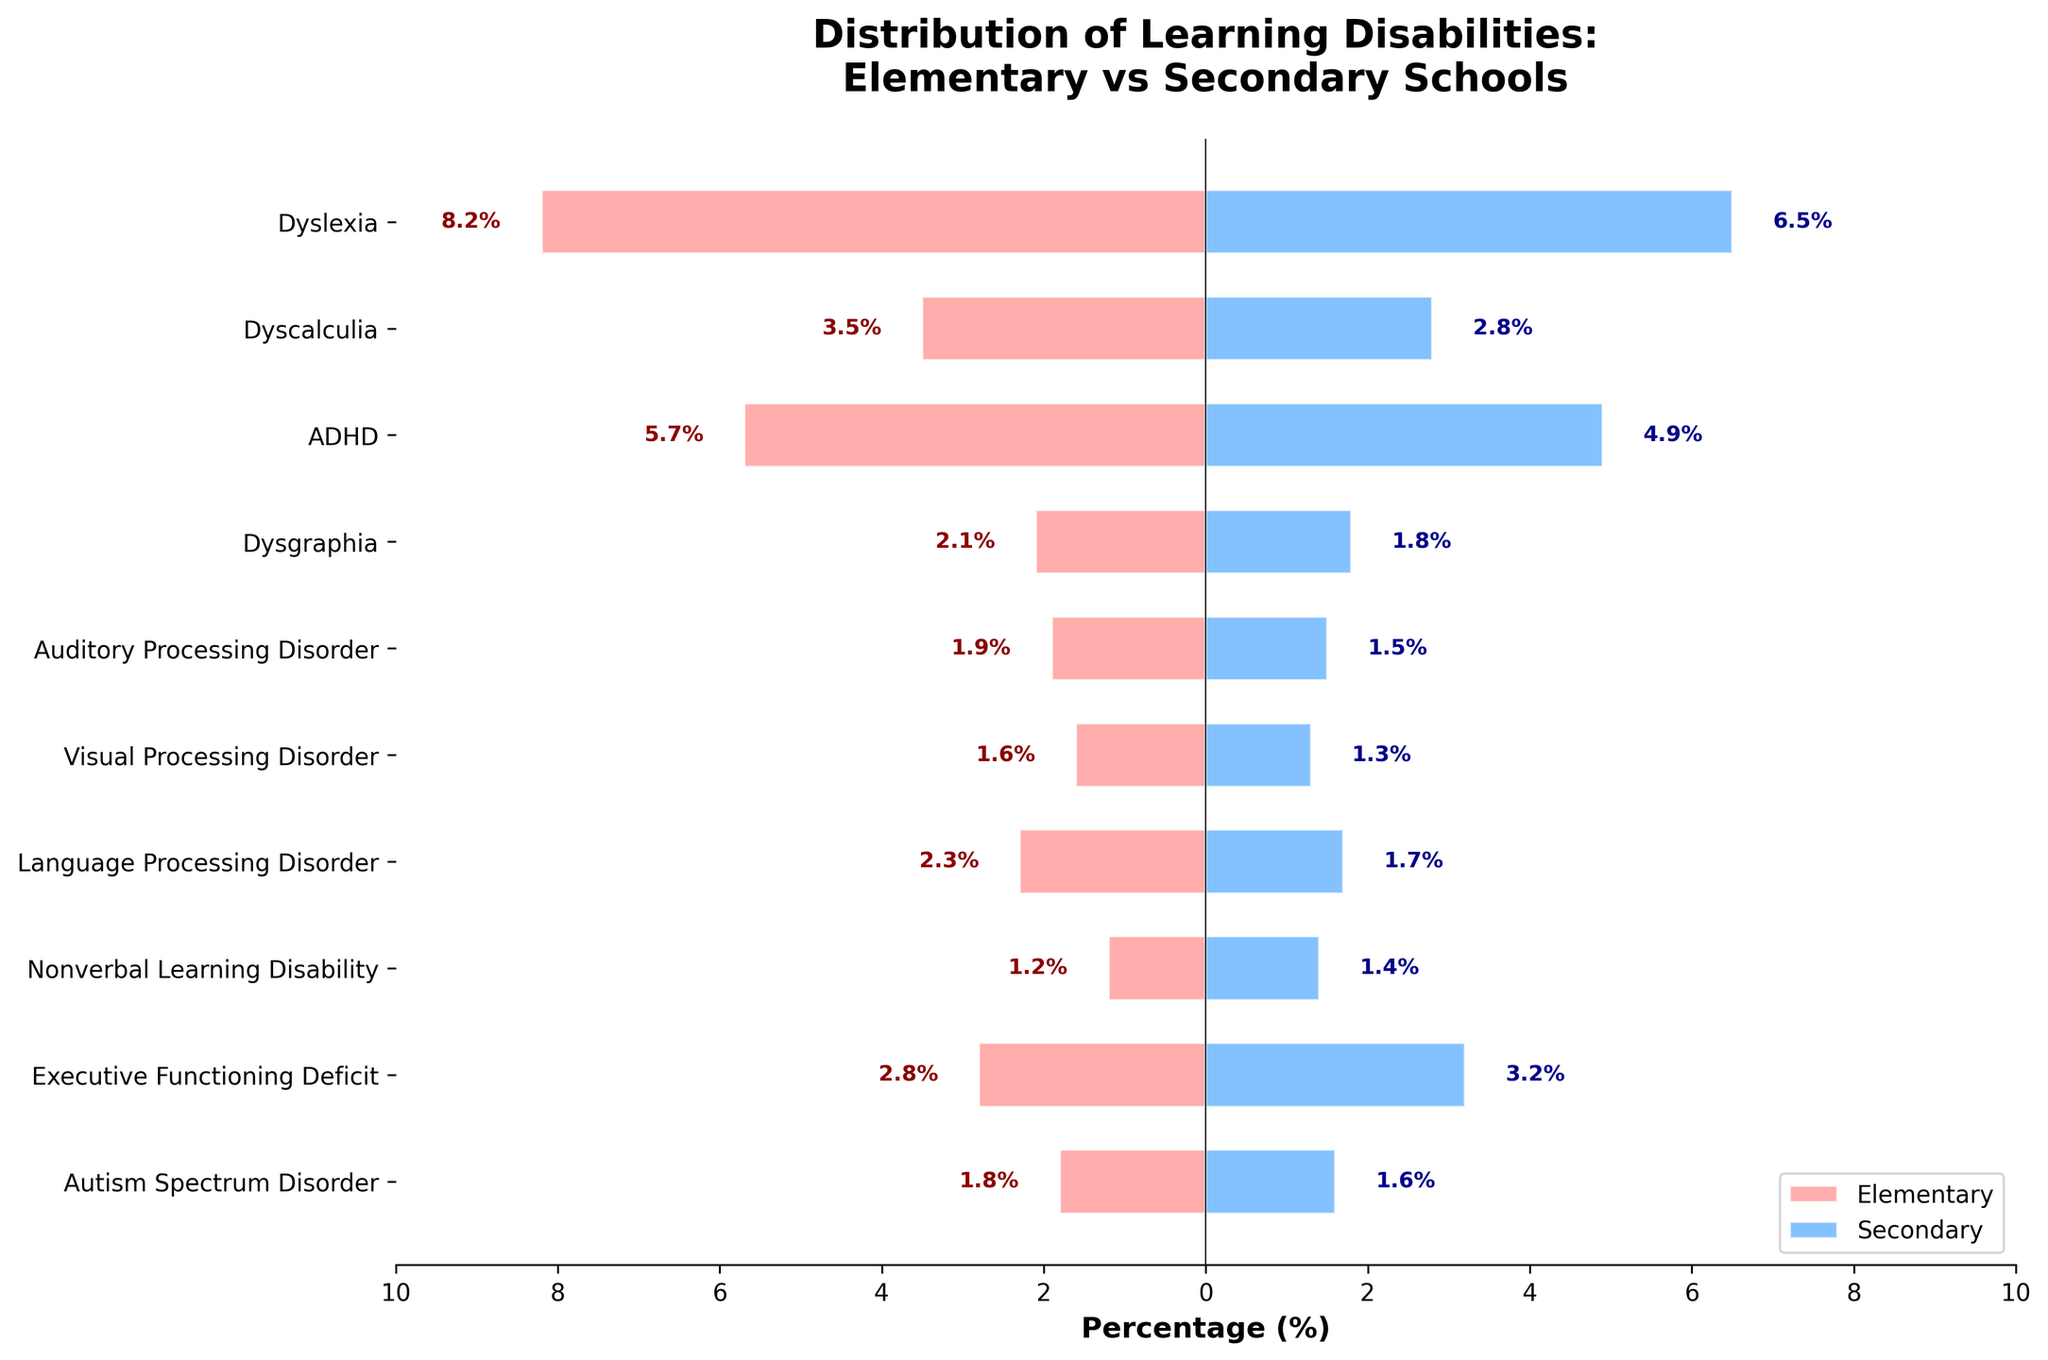What is the distribution of Dyslexia in elementary vs. secondary schools? The bar length indicates 8.2% for elementary and 6.5% for secondary students.
Answer: 8.2% for elementary, 6.5% for secondary What type of learning disability has the highest percentage in elementary school? The longest bar in the elementary side is for Dyslexia with 8.2%.
Answer: Dyslexia Which learning disability has a higher percentage in secondary schools compared to elementary schools? Executive Functioning Deficit has 3.2% in secondary schools, which is higher than its 2.8% in elementary schools.
Answer: Executive Functioning Deficit How do the percentages of Autism Spectrum Disorder compare between elementary and secondary schools? Autism Spectrum Disorder has 1.8% in elementary and 1.6% in secondary schools.
Answer: 1.8% in elementary, 1.6% in secondary What is the average percentage of Dyscalculia and Dysgraphia in elementary schools? Sum the percentages (3.5% + 2.1%) and divide by 2. (3.5 + 2.1) / 2 = 2.8%
Answer: 2.8% Which learning disabilities show more than a 1% difference between elementary and secondary schools? Dyslexia (1.7%), Dyscalculia (0.7%), ADHD (0.8%), and Language Processing Disorder (0.6%) show differences of more than 1%.
Answer: Dyslexia What is the overall trend in the distribution of learning disabilities from elementary to secondary schools? Generally, most learning disabilities show a decrease in percentage from elementary to secondary schools.
Answer: Decrease How does the distribution of Nonverbal Learning Disability differ between elementary and secondary schools? Nonverbal Learning Disability has a higher percentage in secondary (1.4%) than elementary (1.2%) schools.
Answer: Higher in secondary Which learning disability is least common in elementary schools? Nonverbal Learning Disability has the lowest percentage at 1.2% in elementary schools.
Answer: Nonverbal Learning Disability What is the sum of the percentages for Visual Processing Disorder and Auditory Processing Disorder in secondary schools? Add the percentages: 1.3% for Visual Processing Disorder + 1.5% for Auditory Processing Disorder = 2.8%.
Answer: 2.8% 